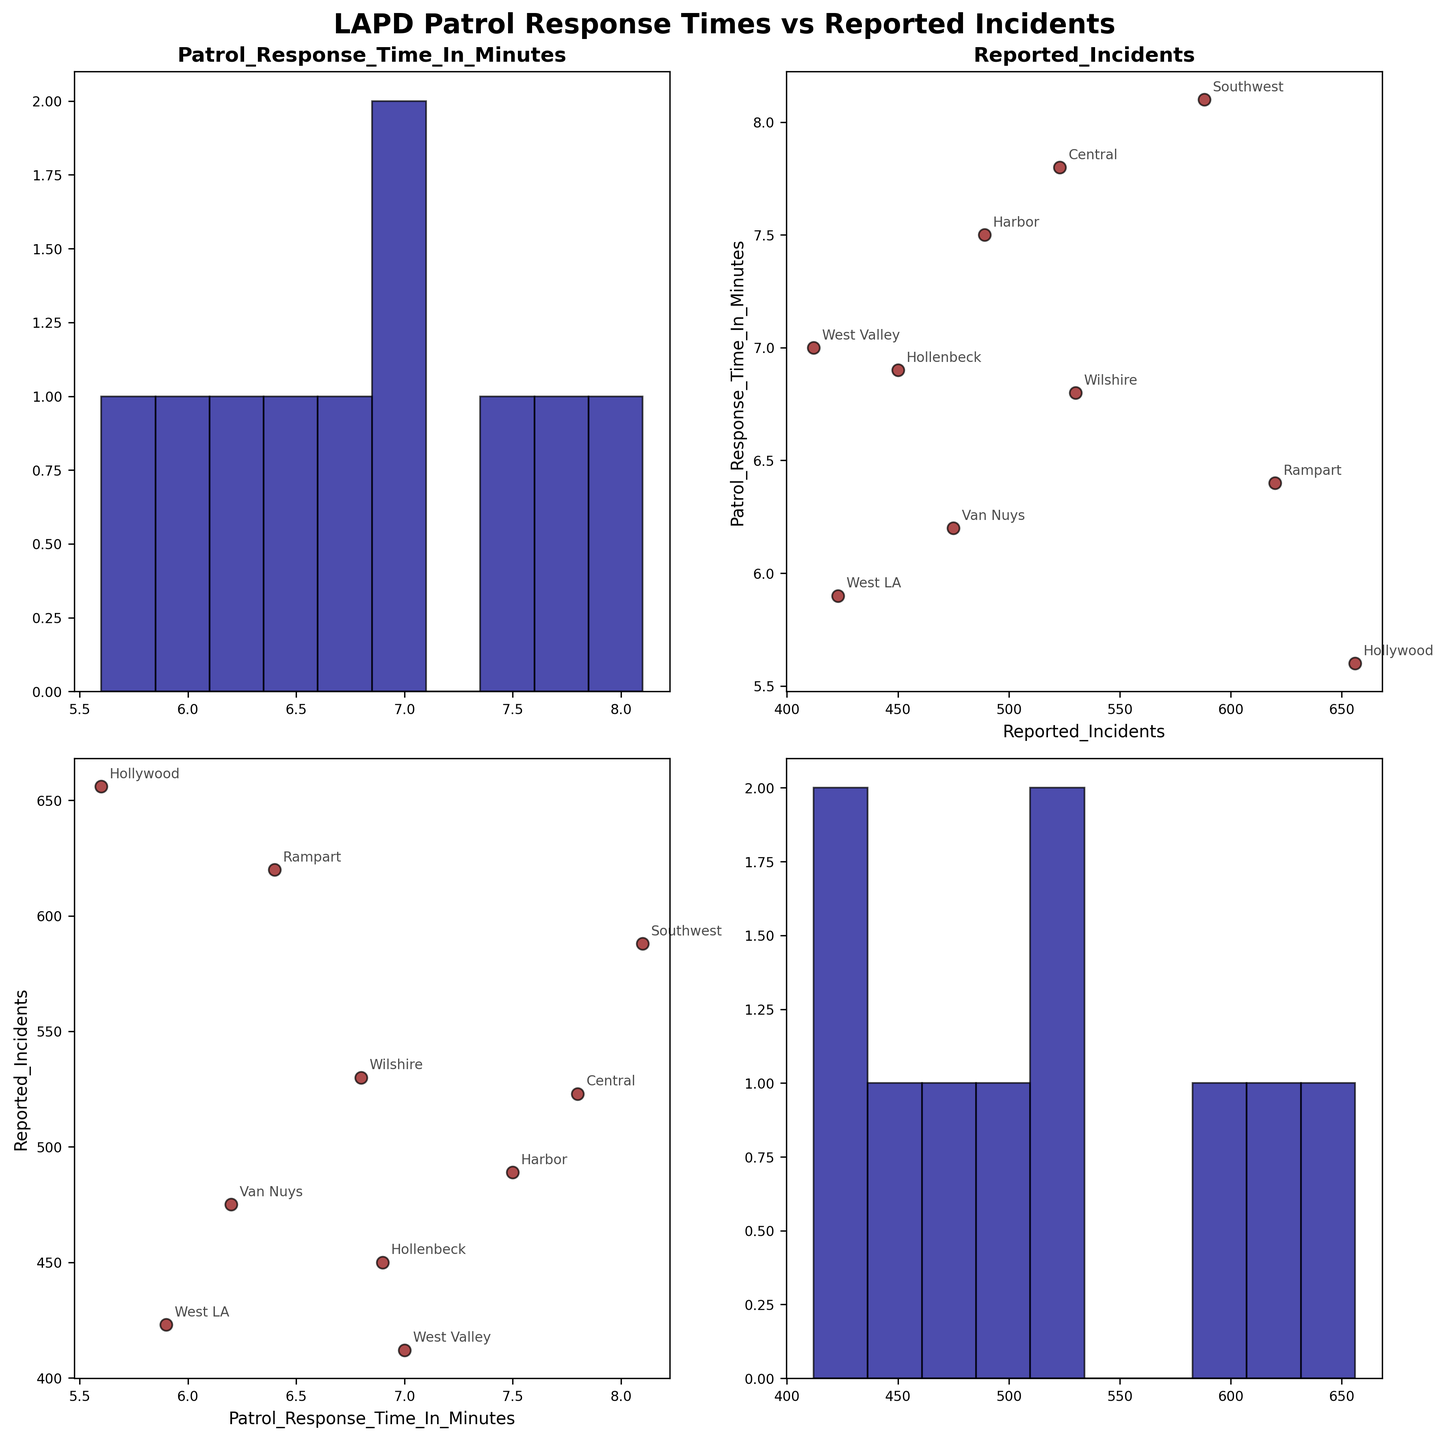What is the title of the figure? The title of the figure is typically the first piece of information we notice, and it is displayed prominently at the top of the plot.
Answer: LAPD Patrol Response Times vs Reported Incidents How many divisions are being analyzed in this plot? The number of divisions can be counted based on the unique labels seen in the annotated points across the scatter plots.
Answer: 10 Which division has the highest number of reported incidents? By observing the y-axis of the scatter plots where 'Reported Incidents' is involved, we can identify the division with the highest y-value.
Answer: Hollywood What is the range of patrol response times observed in the dataset? The range can be determined by identifying the minimum and maximum values on the axis labeled 'Patrol_Response_Time_In_Minutes' across the scatter plots and histograms.
Answer: 5.6 to 8.1 minutes Which two divisions appear to have the closest patrol response times? By comparing the x-axis positions in the scatter plots involving 'Patrol_Response_Time_In_Minutes', we can identify two divisions whose points are closest on the x-axis.
Answer: West LA and Hollywood How many reported incidents does the Rampart division have? We can find the Rampart division in the scatter plot involving 'Reported_Incidents' and check its corresponding y-value.
Answer: 620 Is there a positive correlation between patrol response times and reported incidents? By observing the scatter plot where Patrol_Response_Time is on one axis and Reported_Incidents is on the other, we can determine the type of correlation. If the points tend to move upwards as we move right, it indicates a positive correlation.
Answer: No Which division has the lowest patrol response time? By observing the lowest point in the x-axis of scatter plots involving 'Patrol_Response_Time_In_Minutes', we can identify the division with the lowest patrol response time.
Answer: Hollywood What seems to be the average number of reported incidents across the divisions? To find the average, look at the scatter plots and histograms for 'Reported_Incidents' and estimate the central tendency based on the spread of the points. Calculating precisely involves adding all reported incidents and dividing by the number of divisions.
Answer: Approx. 516开奖结果 